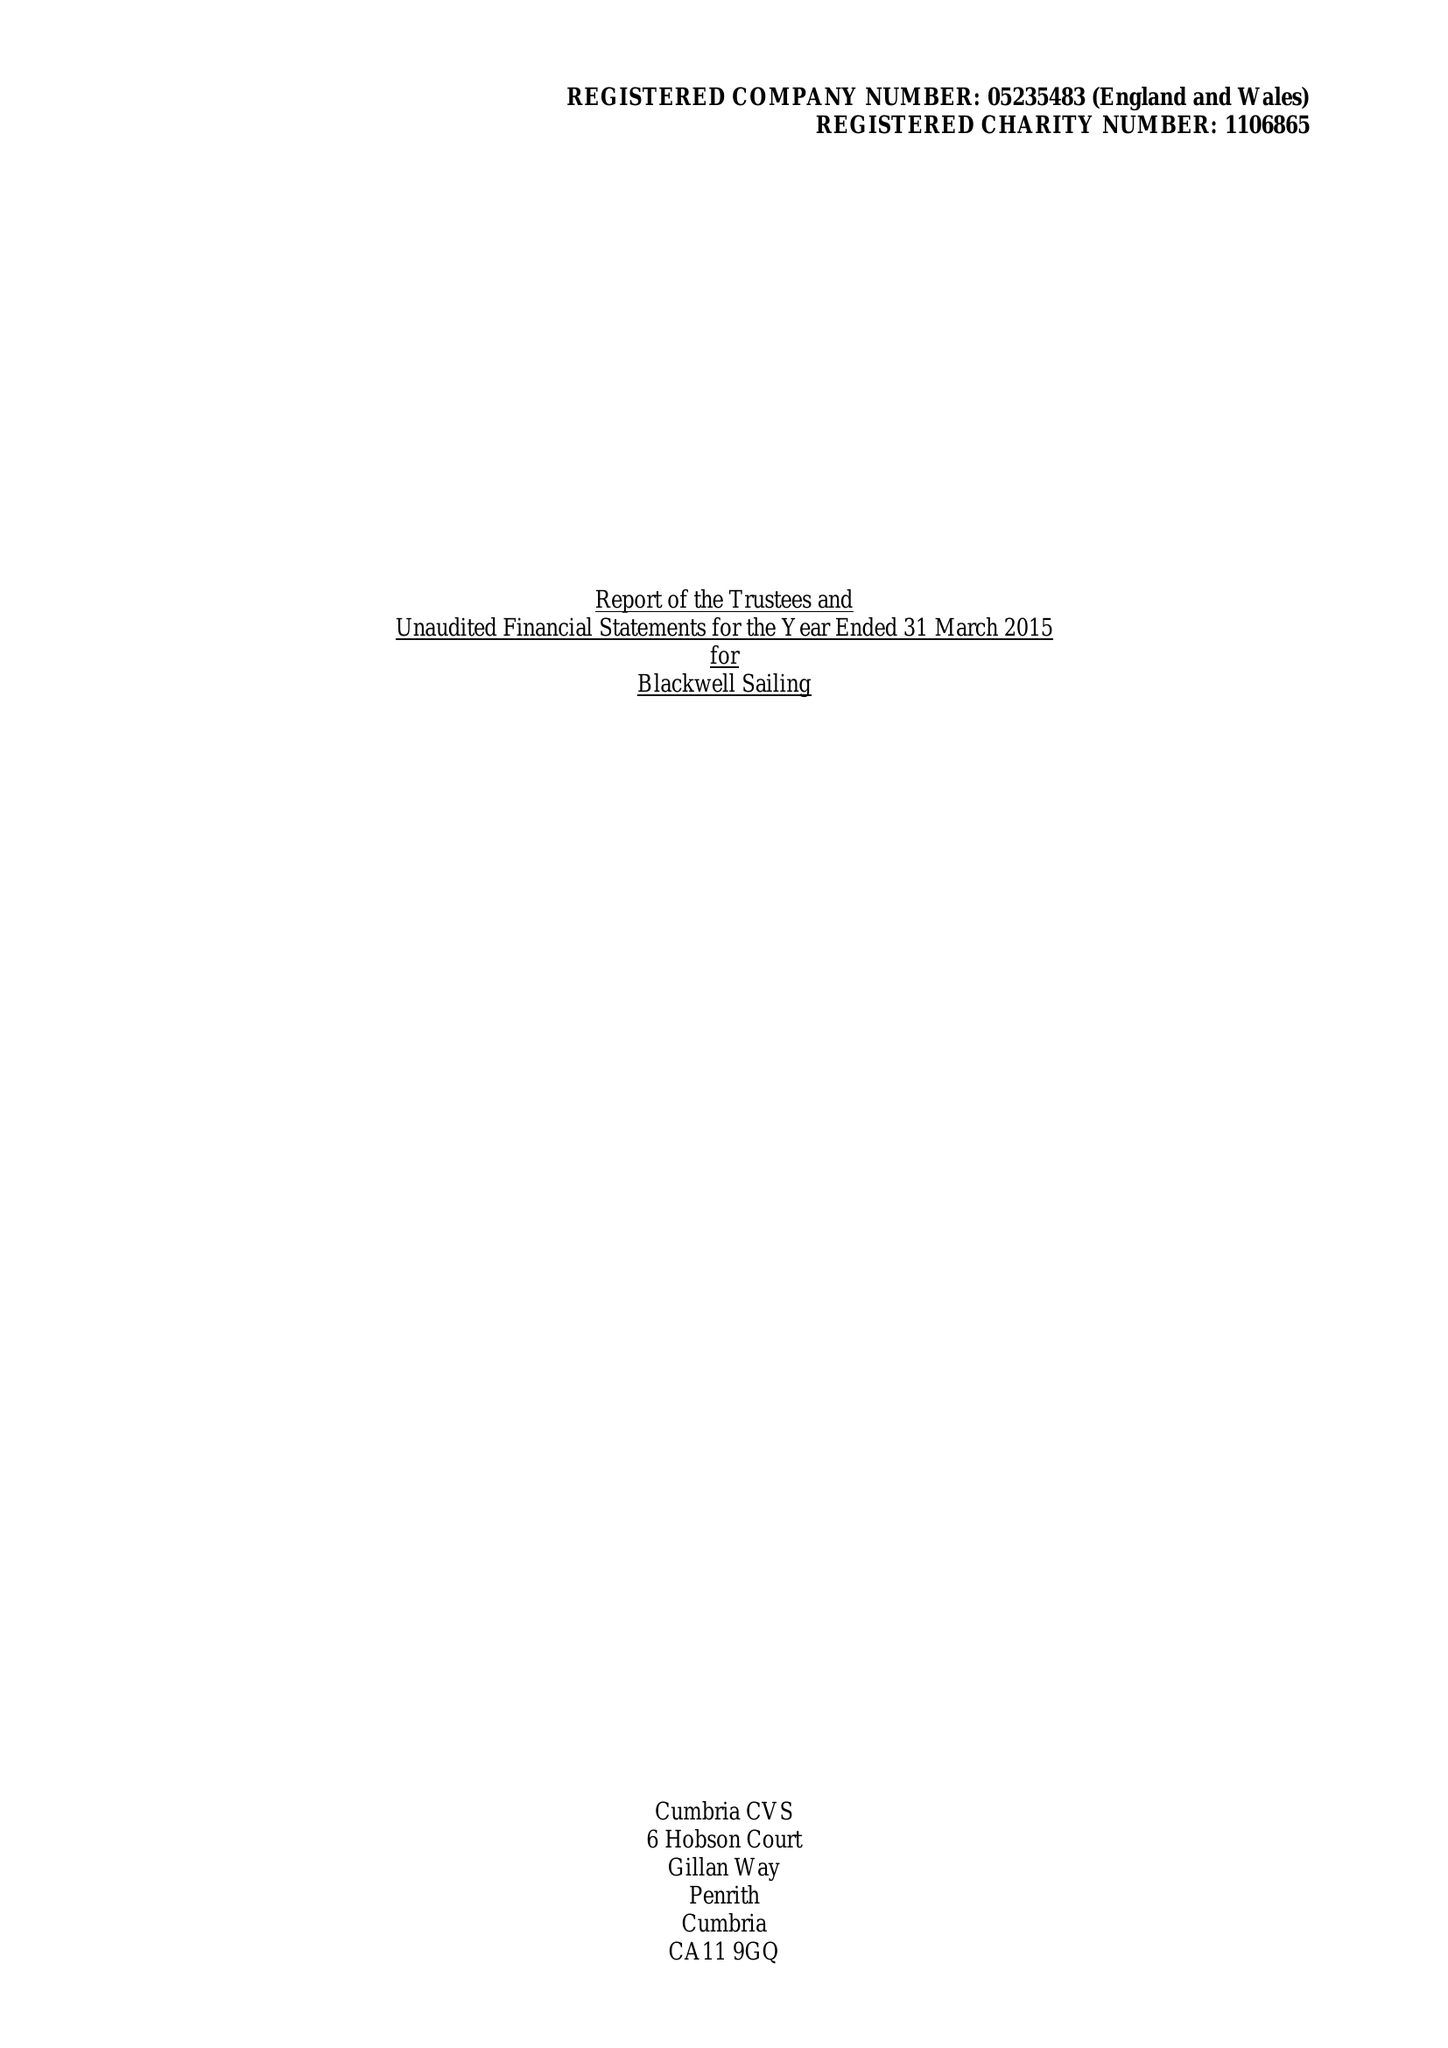What is the value for the spending_annually_in_british_pounds?
Answer the question using a single word or phrase. 60845.00 